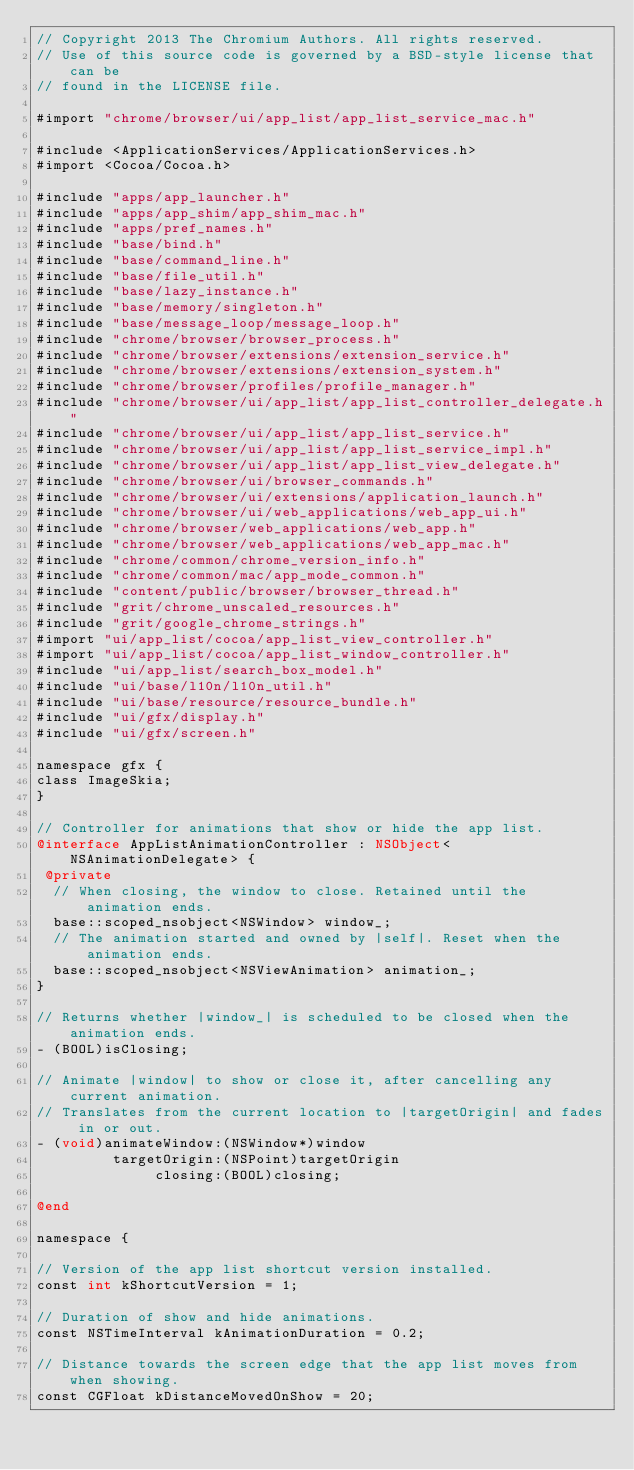<code> <loc_0><loc_0><loc_500><loc_500><_ObjectiveC_>// Copyright 2013 The Chromium Authors. All rights reserved.
// Use of this source code is governed by a BSD-style license that can be
// found in the LICENSE file.

#import "chrome/browser/ui/app_list/app_list_service_mac.h"

#include <ApplicationServices/ApplicationServices.h>
#import <Cocoa/Cocoa.h>

#include "apps/app_launcher.h"
#include "apps/app_shim/app_shim_mac.h"
#include "apps/pref_names.h"
#include "base/bind.h"
#include "base/command_line.h"
#include "base/file_util.h"
#include "base/lazy_instance.h"
#include "base/memory/singleton.h"
#include "base/message_loop/message_loop.h"
#include "chrome/browser/browser_process.h"
#include "chrome/browser/extensions/extension_service.h"
#include "chrome/browser/extensions/extension_system.h"
#include "chrome/browser/profiles/profile_manager.h"
#include "chrome/browser/ui/app_list/app_list_controller_delegate.h"
#include "chrome/browser/ui/app_list/app_list_service.h"
#include "chrome/browser/ui/app_list/app_list_service_impl.h"
#include "chrome/browser/ui/app_list/app_list_view_delegate.h"
#include "chrome/browser/ui/browser_commands.h"
#include "chrome/browser/ui/extensions/application_launch.h"
#include "chrome/browser/ui/web_applications/web_app_ui.h"
#include "chrome/browser/web_applications/web_app.h"
#include "chrome/browser/web_applications/web_app_mac.h"
#include "chrome/common/chrome_version_info.h"
#include "chrome/common/mac/app_mode_common.h"
#include "content/public/browser/browser_thread.h"
#include "grit/chrome_unscaled_resources.h"
#include "grit/google_chrome_strings.h"
#import "ui/app_list/cocoa/app_list_view_controller.h"
#import "ui/app_list/cocoa/app_list_window_controller.h"
#include "ui/app_list/search_box_model.h"
#include "ui/base/l10n/l10n_util.h"
#include "ui/base/resource/resource_bundle.h"
#include "ui/gfx/display.h"
#include "ui/gfx/screen.h"

namespace gfx {
class ImageSkia;
}

// Controller for animations that show or hide the app list.
@interface AppListAnimationController : NSObject<NSAnimationDelegate> {
 @private
  // When closing, the window to close. Retained until the animation ends.
  base::scoped_nsobject<NSWindow> window_;
  // The animation started and owned by |self|. Reset when the animation ends.
  base::scoped_nsobject<NSViewAnimation> animation_;
}

// Returns whether |window_| is scheduled to be closed when the animation ends.
- (BOOL)isClosing;

// Animate |window| to show or close it, after cancelling any current animation.
// Translates from the current location to |targetOrigin| and fades in or out.
- (void)animateWindow:(NSWindow*)window
         targetOrigin:(NSPoint)targetOrigin
              closing:(BOOL)closing;

@end

namespace {

// Version of the app list shortcut version installed.
const int kShortcutVersion = 1;

// Duration of show and hide animations.
const NSTimeInterval kAnimationDuration = 0.2;

// Distance towards the screen edge that the app list moves from when showing.
const CGFloat kDistanceMovedOnShow = 20;
</code> 